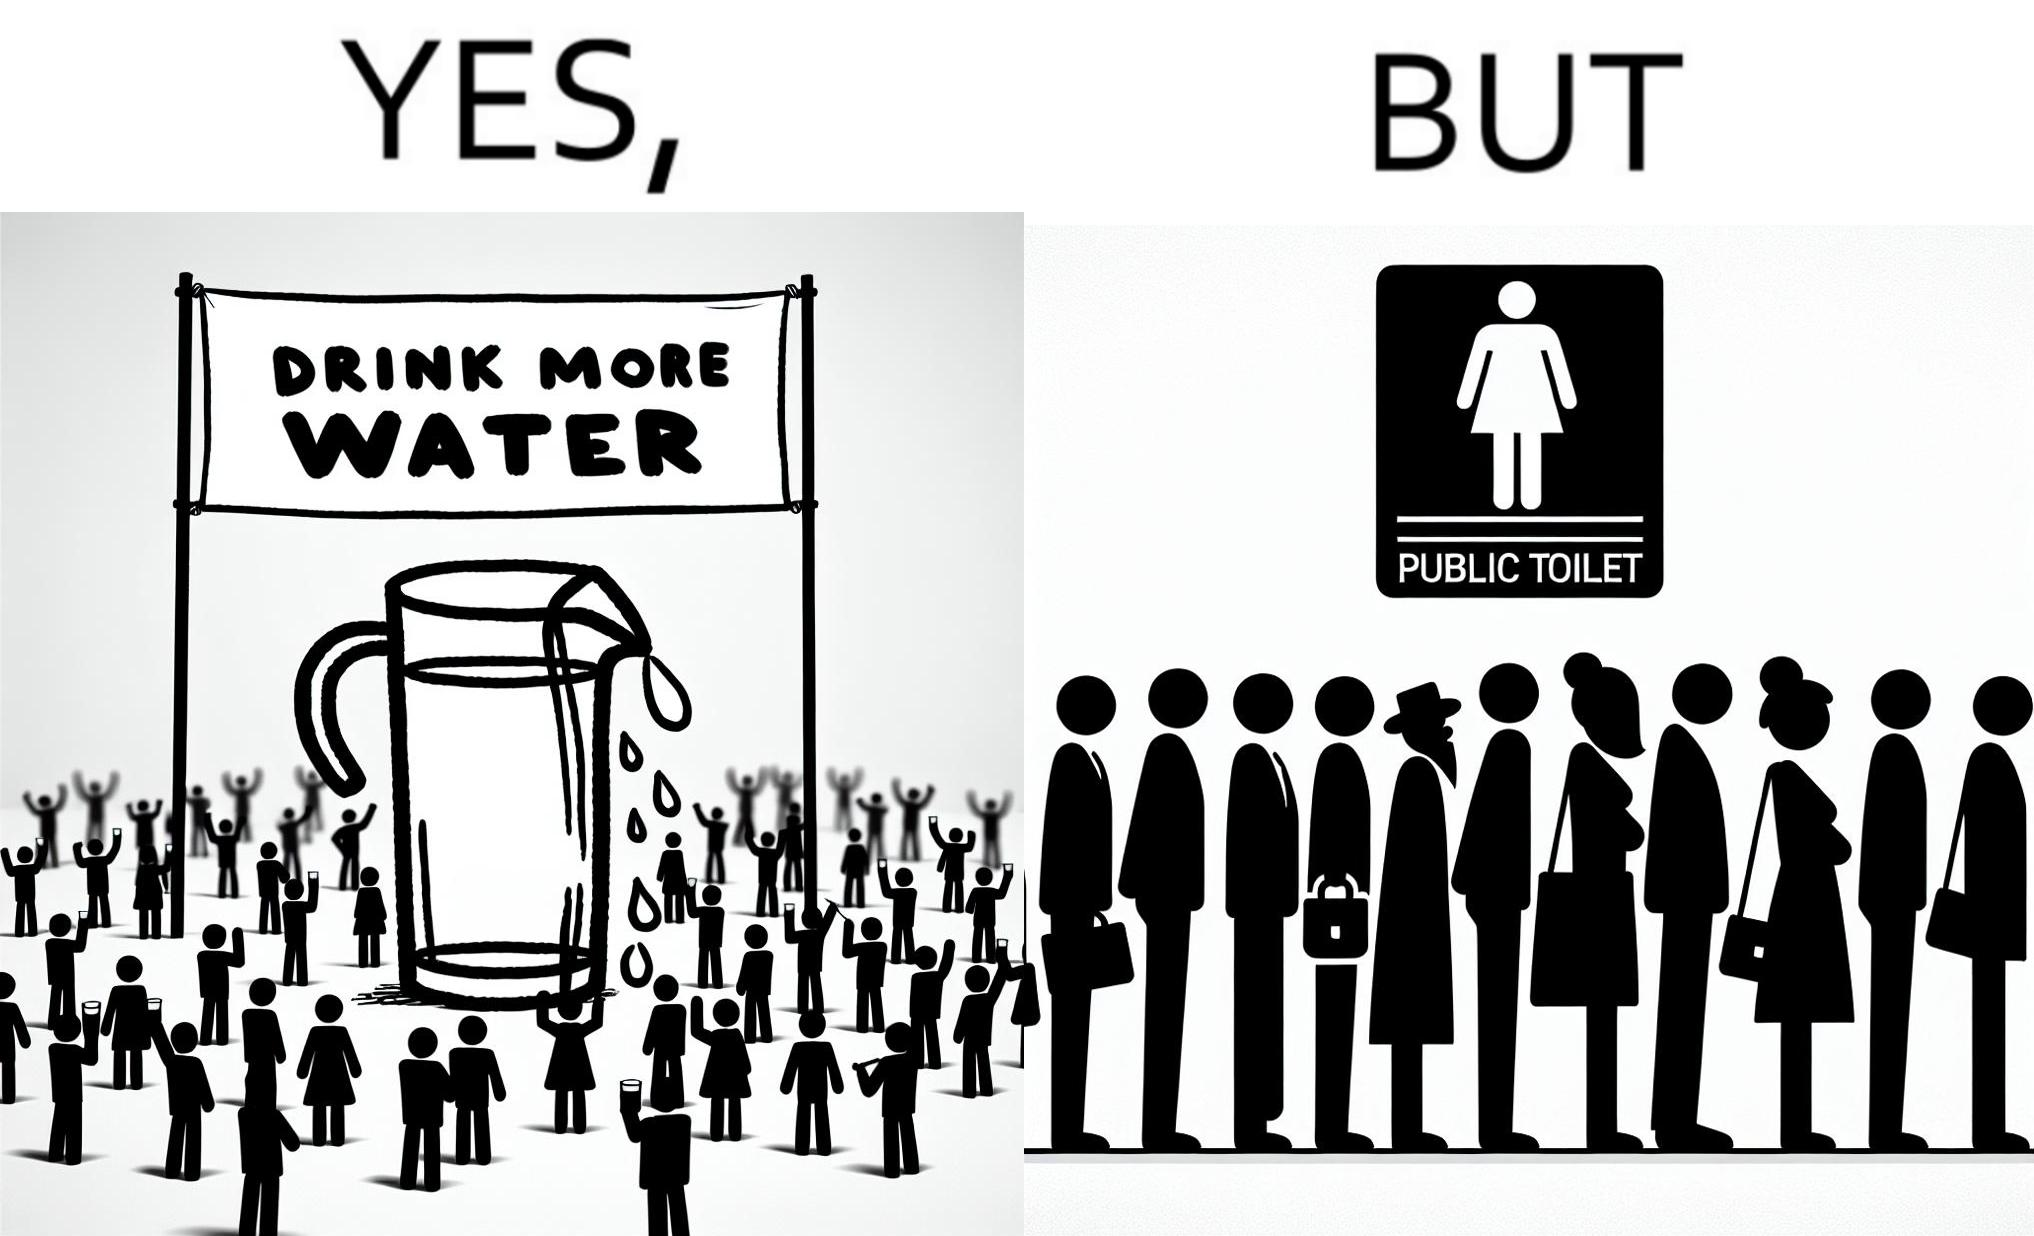Describe the contrast between the left and right parts of this image. In the left part of the image: A banner that says "Drink more water" with an image of a jug pouring water into a glass. In the right part of the image: a very long queue in front of the public toilet 